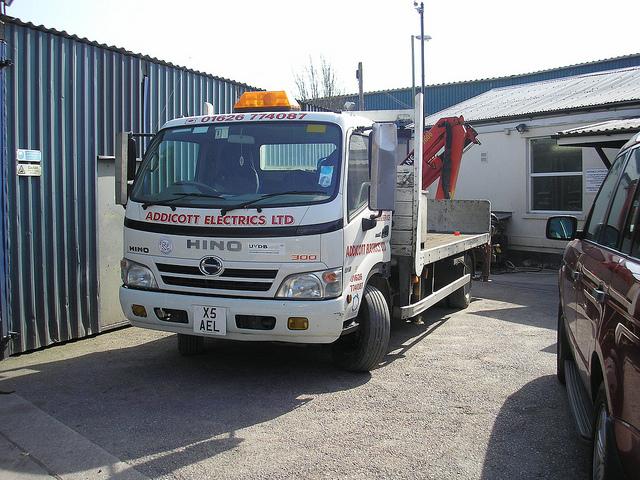Does the truck belong to an electric company?
Give a very brief answer. Yes. Is the white truck's steering wheel turned to the left?
Write a very short answer. Yes. How many vehicles are in the picture?
Quick response, please. 2. What type of trucks are these?
Be succinct. Tow. 